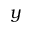<formula> <loc_0><loc_0><loc_500><loc_500>y</formula> 